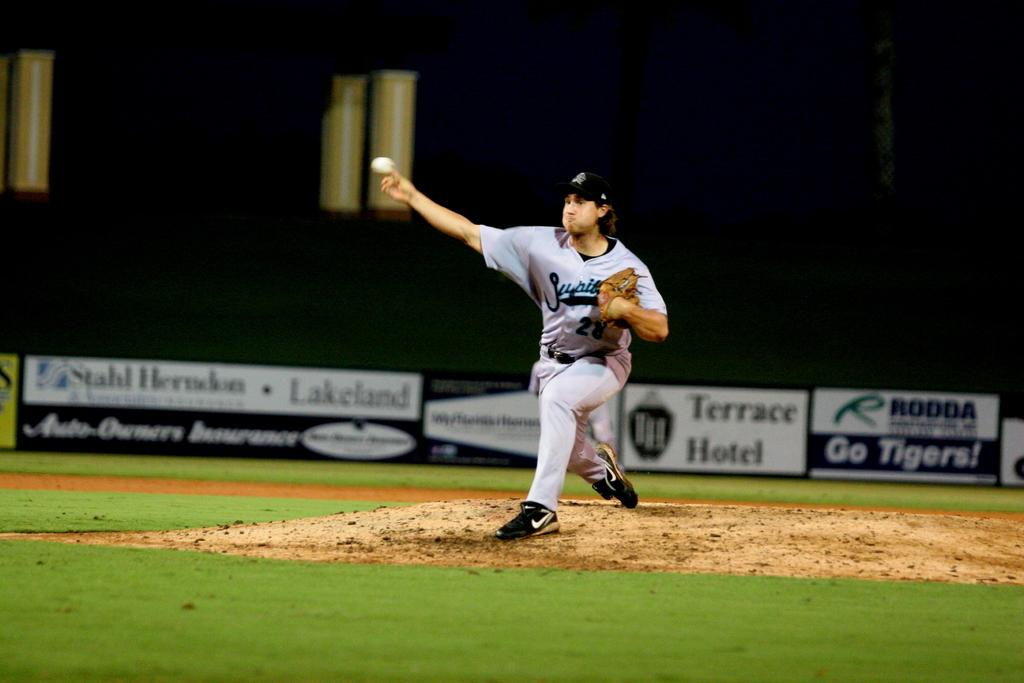Provide a one-sentence caption for the provided image. A baseball pitcher wears a uniform with the number 28 on it. 